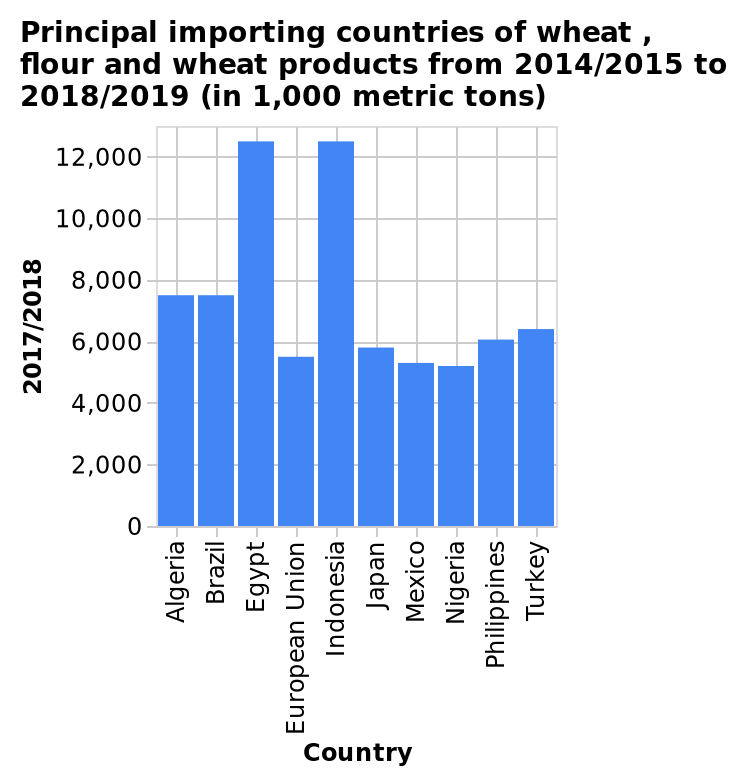<image>
What does the y-axis measure?  The y-axis measures 2017/2018. What does the x-axis measure?  The x-axis measures Country. What is the title of the bar chart?  The title of the bar chart is "Principal importing countries of wheat, flour and wheat products from 2014/2015 to 2018/2019 (in 1,000 metric tons)." Which country imported more wheat and flour products between Indonesia and Egypt? The given information does not specify which country imported more. 